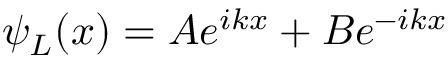Convert formula to latex. <formula><loc_0><loc_0><loc_500><loc_500>\psi _ { L } ( x ) = A e ^ { i k x } + B e ^ { - i k x }</formula> 